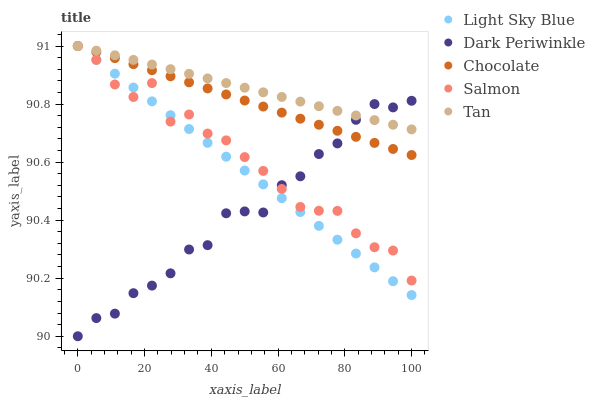Does Dark Periwinkle have the minimum area under the curve?
Answer yes or no. Yes. Does Tan have the maximum area under the curve?
Answer yes or no. Yes. Does Light Sky Blue have the minimum area under the curve?
Answer yes or no. No. Does Light Sky Blue have the maximum area under the curve?
Answer yes or no. No. Is Chocolate the smoothest?
Answer yes or no. Yes. Is Salmon the roughest?
Answer yes or no. Yes. Is Light Sky Blue the smoothest?
Answer yes or no. No. Is Light Sky Blue the roughest?
Answer yes or no. No. Does Dark Periwinkle have the lowest value?
Answer yes or no. Yes. Does Light Sky Blue have the lowest value?
Answer yes or no. No. Does Chocolate have the highest value?
Answer yes or no. Yes. Does Dark Periwinkle have the highest value?
Answer yes or no. No. Does Dark Periwinkle intersect Salmon?
Answer yes or no. Yes. Is Dark Periwinkle less than Salmon?
Answer yes or no. No. Is Dark Periwinkle greater than Salmon?
Answer yes or no. No. 